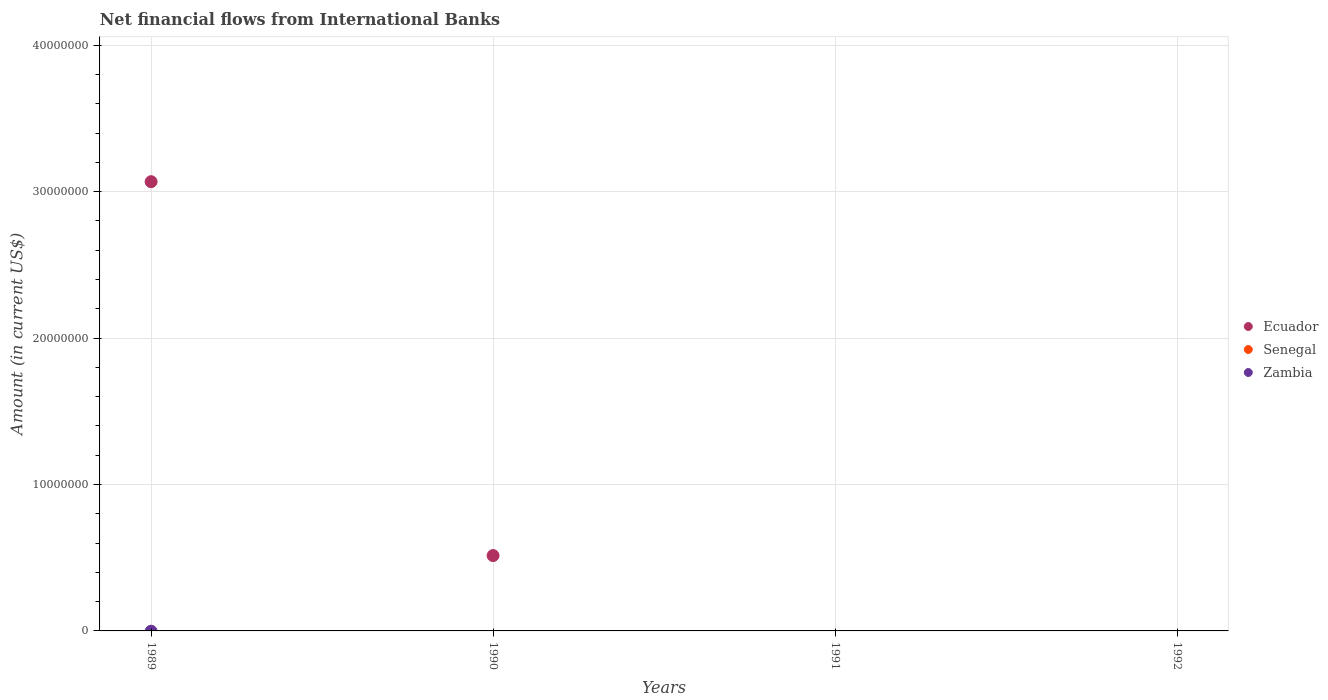How many different coloured dotlines are there?
Ensure brevity in your answer.  1. Is the number of dotlines equal to the number of legend labels?
Your answer should be very brief. No. What is the net financial aid flows in Ecuador in 1991?
Keep it short and to the point. 0. Across all years, what is the maximum net financial aid flows in Ecuador?
Give a very brief answer. 3.07e+07. Across all years, what is the minimum net financial aid flows in Zambia?
Keep it short and to the point. 0. What is the difference between the net financial aid flows in Ecuador in 1989 and that in 1990?
Keep it short and to the point. 2.55e+07. In how many years, is the net financial aid flows in Ecuador greater than 36000000 US$?
Your answer should be compact. 0. What is the ratio of the net financial aid flows in Ecuador in 1989 to that in 1990?
Your response must be concise. 5.96. What is the difference between the highest and the lowest net financial aid flows in Ecuador?
Provide a succinct answer. 3.07e+07. In how many years, is the net financial aid flows in Ecuador greater than the average net financial aid flows in Ecuador taken over all years?
Offer a terse response. 1. Is the net financial aid flows in Zambia strictly greater than the net financial aid flows in Senegal over the years?
Provide a short and direct response. No. How many dotlines are there?
Provide a short and direct response. 1. Are the values on the major ticks of Y-axis written in scientific E-notation?
Ensure brevity in your answer.  No. Where does the legend appear in the graph?
Provide a short and direct response. Center right. How many legend labels are there?
Your answer should be compact. 3. How are the legend labels stacked?
Your answer should be compact. Vertical. What is the title of the graph?
Keep it short and to the point. Net financial flows from International Banks. Does "Netherlands" appear as one of the legend labels in the graph?
Your answer should be very brief. No. What is the label or title of the Y-axis?
Your answer should be very brief. Amount (in current US$). What is the Amount (in current US$) in Ecuador in 1989?
Provide a succinct answer. 3.07e+07. What is the Amount (in current US$) in Senegal in 1989?
Offer a very short reply. 0. What is the Amount (in current US$) in Ecuador in 1990?
Ensure brevity in your answer.  5.15e+06. What is the Amount (in current US$) of Zambia in 1990?
Keep it short and to the point. 0. What is the Amount (in current US$) in Ecuador in 1991?
Offer a terse response. 0. What is the Amount (in current US$) of Senegal in 1991?
Your answer should be compact. 0. What is the Amount (in current US$) in Ecuador in 1992?
Give a very brief answer. 0. What is the Amount (in current US$) in Zambia in 1992?
Provide a short and direct response. 0. Across all years, what is the maximum Amount (in current US$) in Ecuador?
Offer a very short reply. 3.07e+07. What is the total Amount (in current US$) in Ecuador in the graph?
Your answer should be very brief. 3.58e+07. What is the difference between the Amount (in current US$) of Ecuador in 1989 and that in 1990?
Provide a short and direct response. 2.55e+07. What is the average Amount (in current US$) of Ecuador per year?
Provide a succinct answer. 8.96e+06. What is the average Amount (in current US$) of Senegal per year?
Your response must be concise. 0. What is the ratio of the Amount (in current US$) of Ecuador in 1989 to that in 1990?
Keep it short and to the point. 5.96. What is the difference between the highest and the lowest Amount (in current US$) of Ecuador?
Provide a succinct answer. 3.07e+07. 